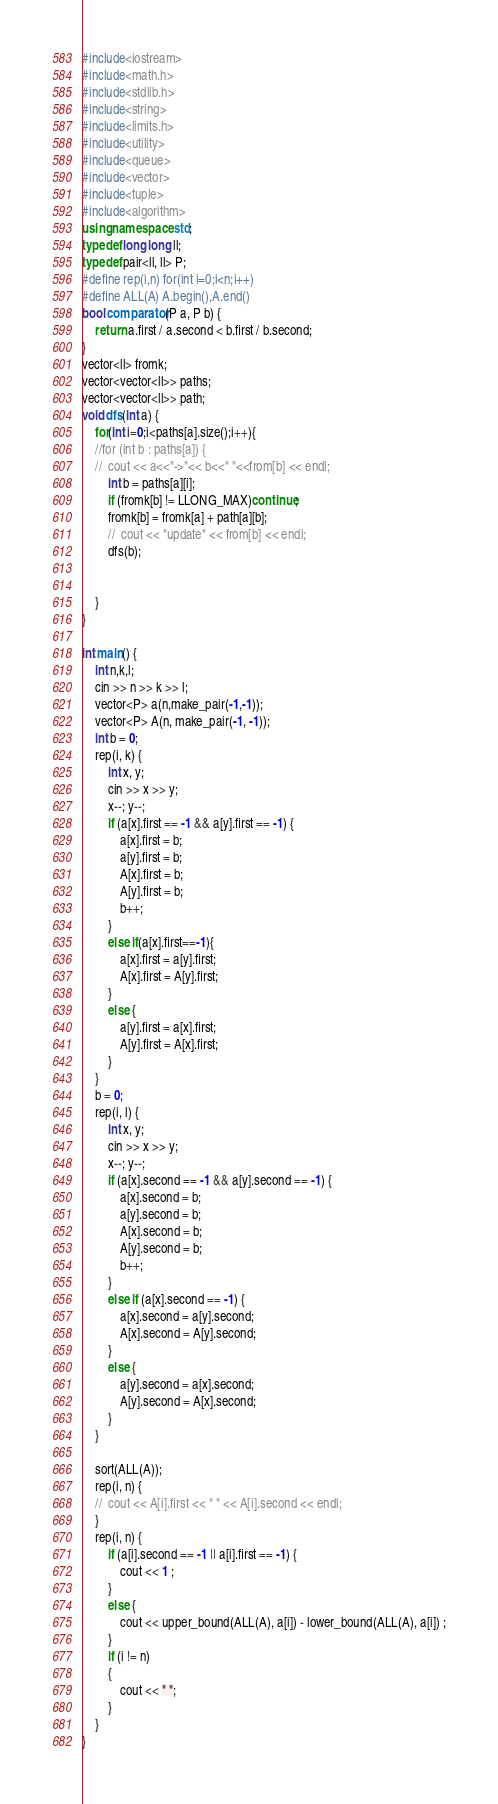Convert code to text. <code><loc_0><loc_0><loc_500><loc_500><_C++_>#include<iostream>
#include<math.h>
#include<stdlib.h>
#include<string>
#include<limits.h>
#include<utility>
#include<queue>
#include<vector>
#include<tuple>
#include<algorithm>
using namespace std;
typedef long long ll;
typedef pair<ll, ll> P;
#define rep(i,n) for(int i=0;i<n;i++)
#define ALL(A) A.begin(),A.end()
bool comparator(P a, P b) {
	return a.first / a.second < b.first / b.second;
}
vector<ll> fromk;
vector<vector<ll>> paths;
vector<vector<ll>> path;
void dfs(int a) {
	for(int i=0;i<paths[a].size();i++){
	//for (int b : paths[a]) {
	//	cout << a<<"->"<< b<<" "<<from[b] << endl;
		int b = paths[a][i];
		if (fromk[b] != LLONG_MAX)continue;
		fromk[b] = fromk[a] + path[a][b];
		//	cout << "update" << from[b] << endl;
		dfs(b);
		
		
	}
}

int main() {
	int n,k,l;
	cin >> n >> k >> l;
	vector<P> a(n,make_pair(-1,-1));
	vector<P> A(n, make_pair(-1, -1));
	int b = 0;
	rep(i, k) {
		int x, y;
		cin >> x >> y;
		x--; y--;
		if (a[x].first == -1 && a[y].first == -1) {
			a[x].first = b;
			a[y].first = b;
			A[x].first = b;
			A[y].first = b;
			b++;
		}
		else if(a[x].first==-1){
			a[x].first = a[y].first;
			A[x].first = A[y].first;
		}
		else {
			a[y].first = a[x].first;
			A[y].first = A[x].first;
		}
	}
	b = 0;
	rep(i, l) {
		int x, y;
		cin >> x >> y;
		x--; y--;
		if (a[x].second == -1 && a[y].second == -1) {
			a[x].second = b;
			a[y].second = b;
			A[x].second = b;
			A[y].second = b;
			b++;
		}
		else if (a[x].second == -1) {
			a[x].second = a[y].second;
			A[x].second = A[y].second;
		}
		else {
			a[y].second = a[x].second;
			A[y].second = A[x].second;
		}
	}
	
	sort(ALL(A));
	rep(i, n) {
	//	cout << A[i].first << " " << A[i].second << endl;
	}
	rep(i, n) {
		if (a[i].second == -1 || a[i].first == -1) {
			cout << 1 ;
		}
		else {
			cout << upper_bound(ALL(A), a[i]) - lower_bound(ALL(A), a[i]) ;
		}
		if (i != n)
		{
			cout << " ";
		}
	}
}
</code> 